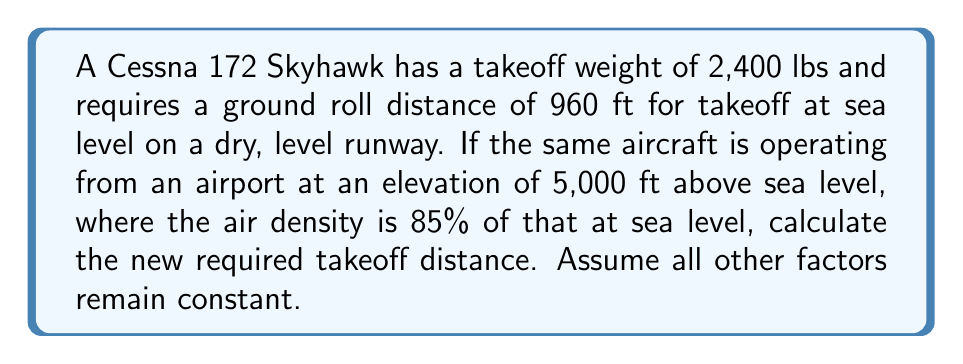Can you answer this question? To solve this problem, we'll follow these steps:

1) First, recall that takeoff distance is inversely proportional to air density. This means that as air density decreases, takeoff distance increases.

2) Let's define our variables:
   $d_0$ = original takeoff distance = 960 ft
   $\rho_0$ = air density at sea level (100%)
   $\rho_1$ = air density at 5,000 ft (85% of sea level)
   $d_1$ = new takeoff distance (what we're solving for)

3) We can express the relationship between takeoff distance and air density as:

   $$\frac{d_1}{d_0} = \frac{\rho_0}{\rho_1}$$

4) We know that $\rho_1 = 0.85\rho_0$, so we can substitute this:

   $$\frac{d_1}{960} = \frac{\rho_0}{0.85\rho_0}$$

5) Simplify:

   $$\frac{d_1}{960} = \frac{1}{0.85}$$

6) Multiply both sides by 960:

   $$d_1 = 960 \cdot \frac{1}{0.85}$$

7) Calculate:

   $$d_1 = 960 \cdot 1.1765 = 1,129.4 \text{ ft}$$

8) Round to the nearest foot:

   $$d_1 \approx 1,129 \text{ ft}$$

Thus, the new required takeoff distance at 5,000 ft elevation is approximately 1,129 ft.
Answer: 1,129 ft 